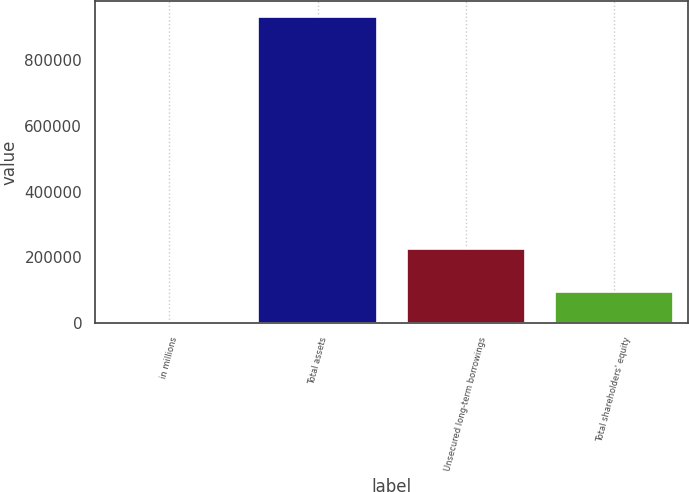Convert chart to OTSL. <chart><loc_0><loc_0><loc_500><loc_500><bar_chart><fcel>in millions<fcel>Total assets<fcel>Unsecured long-term borrowings<fcel>Total shareholders' equity<nl><fcel>2018<fcel>931796<fcel>224149<fcel>94995.8<nl></chart> 